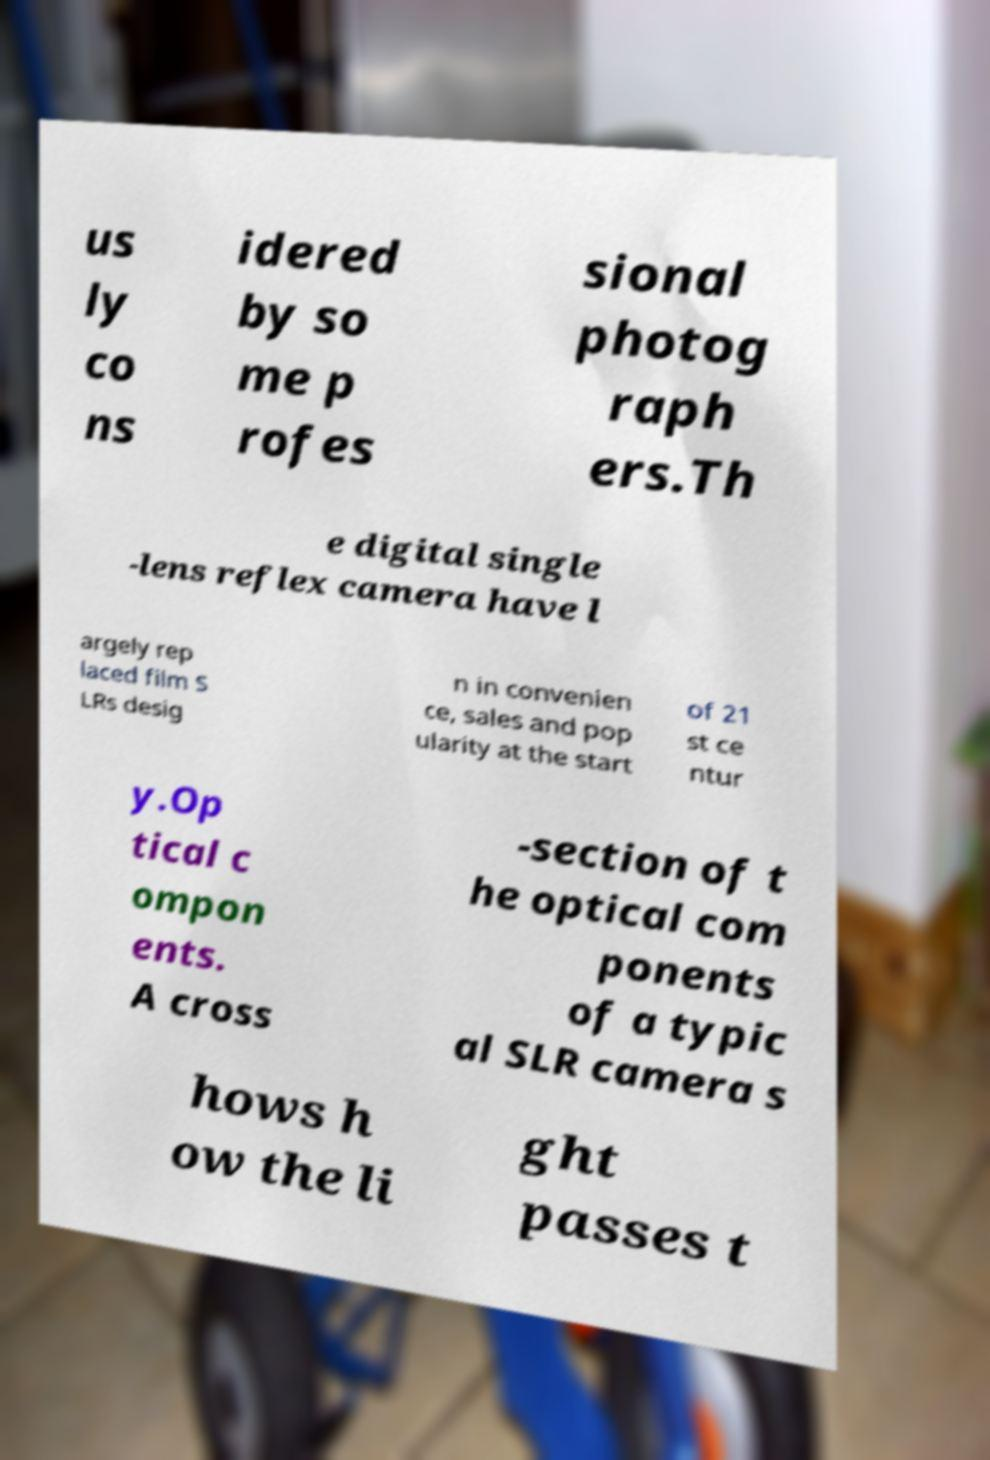Can you read and provide the text displayed in the image?This photo seems to have some interesting text. Can you extract and type it out for me? us ly co ns idered by so me p rofes sional photog raph ers.Th e digital single -lens reflex camera have l argely rep laced film S LRs desig n in convenien ce, sales and pop ularity at the start of 21 st ce ntur y.Op tical c ompon ents. A cross -section of t he optical com ponents of a typic al SLR camera s hows h ow the li ght passes t 